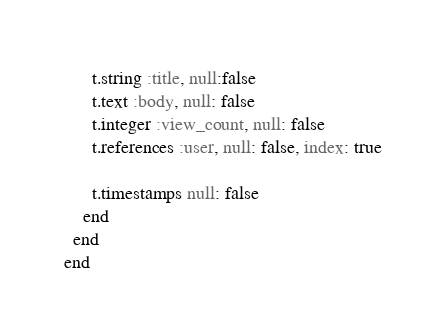Convert code to text. <code><loc_0><loc_0><loc_500><loc_500><_Ruby_>      t.string :title, null:false
      t.text :body, null: false
      t.integer :view_count, null: false
      t.references :user, null: false, index: true

      t.timestamps null: false
    end
  end
end
</code> 